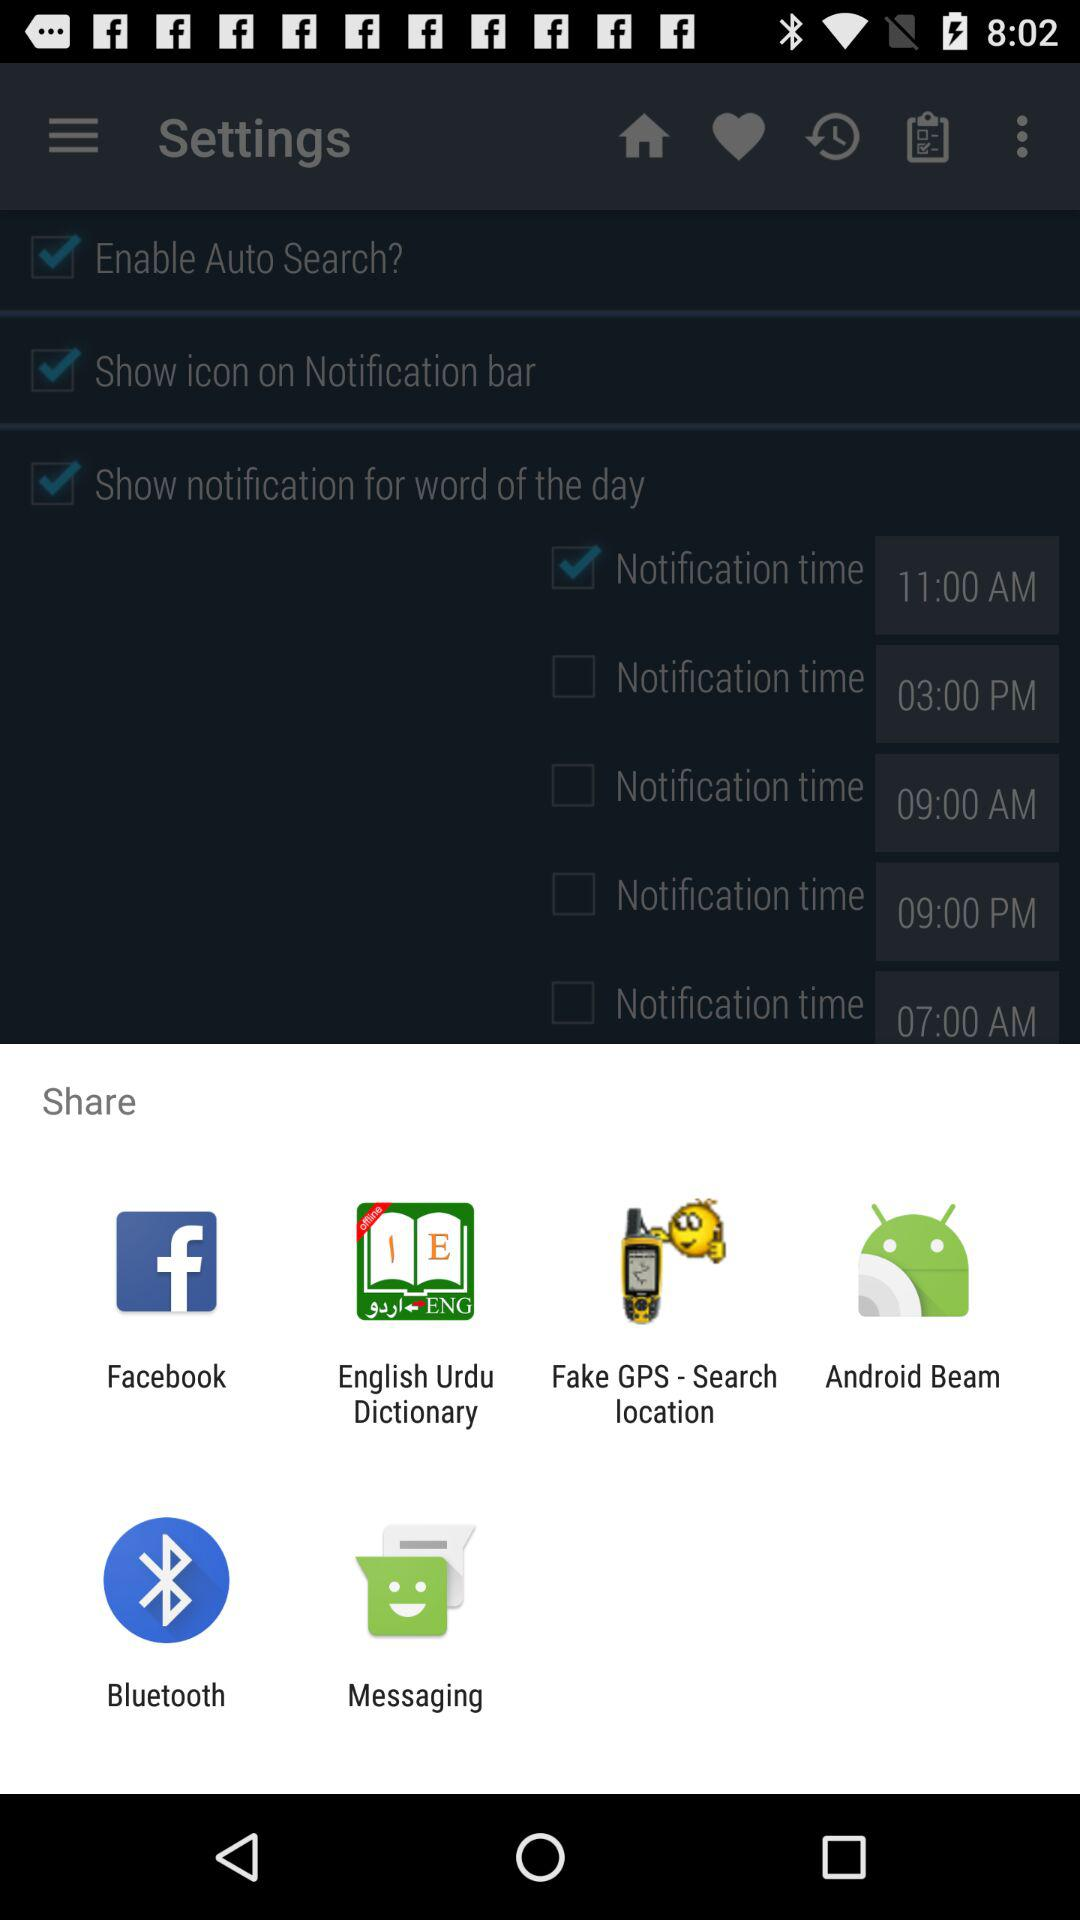What is the selected notification time? The selected notification time is 11:00 AM. 